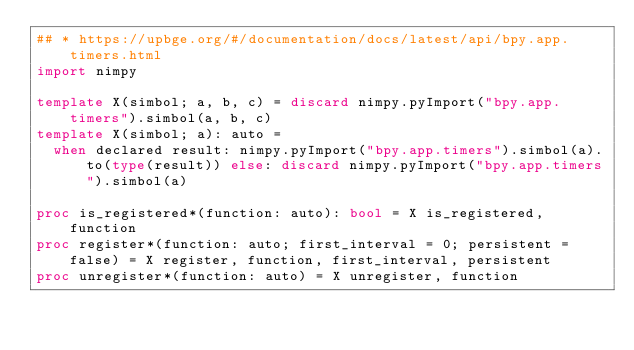<code> <loc_0><loc_0><loc_500><loc_500><_Nim_>## * https://upbge.org/#/documentation/docs/latest/api/bpy.app.timers.html
import nimpy

template X(simbol; a, b, c) = discard nimpy.pyImport("bpy.app.timers").simbol(a, b, c)
template X(simbol; a): auto =
  when declared result: nimpy.pyImport("bpy.app.timers").simbol(a).to(type(result)) else: discard nimpy.pyImport("bpy.app.timers").simbol(a)

proc is_registered*(function: auto): bool = X is_registered, function
proc register*(function: auto; first_interval = 0; persistent = false) = X register, function, first_interval, persistent
proc unregister*(function: auto) = X unregister, function
</code> 